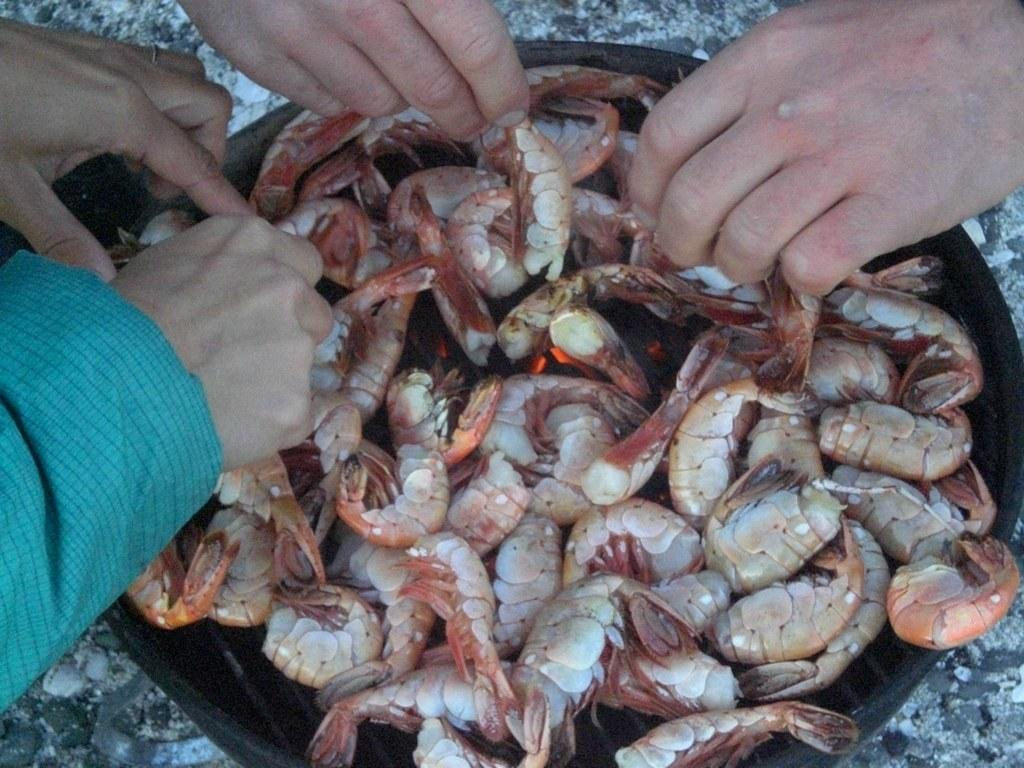What is the color of the object in the image? The object in the image is black in color. What type of food can be seen in the image? There are shrimps in the image. What are the colors of the shrimps? The shrimps are cream and red in color. Whose hands are visible in the image? The hands of a few persons are visible in the image. What type of marble is being used to weigh the shrimps in the image? There is no marble or scale present in the image, and therefore no such activity can be observed. 